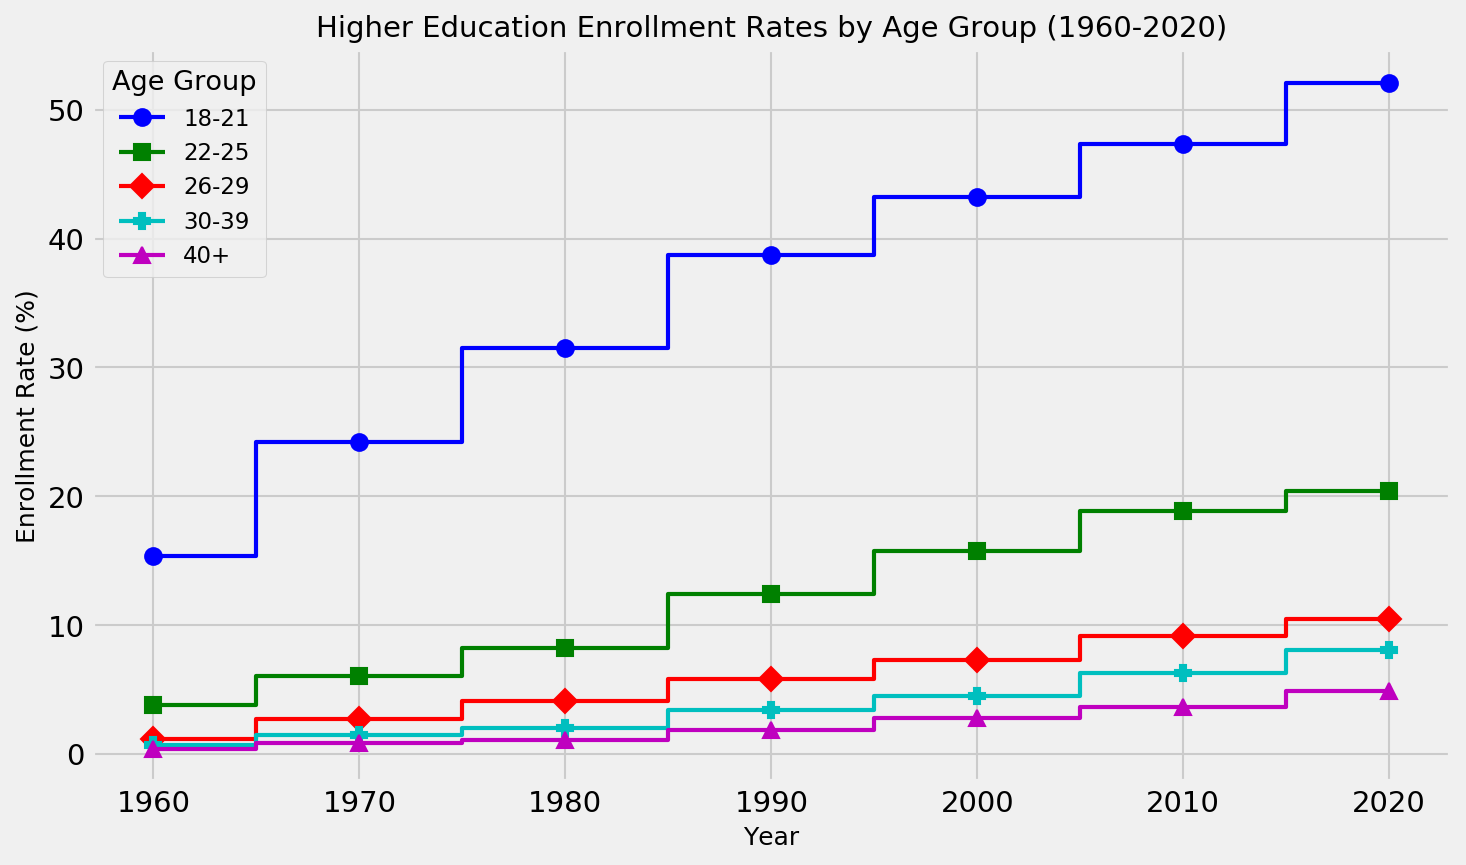What's the enrollment rate trend for the 18-21 age group from 1960 to 2020? From 1960 to 2020, you observe a consistent increase in enrollment rates for the 18-21 age group. Specifically, the rates progress from 15.4% in 1960, to 24.2% in 1970, 31.5% in 1980, 38.7% in 1990, 43.2% in 2000, 47.3% in 2010, and reach 52.1% in 2020.
Answer: Increasing trend Which age group showed the highest enrollment rate increase between 1960 and 2020? To determine this, calculate the differences in enrollment rates for each age group between 1960 and 2020. For the 18-21 age group: 52.1 - 15.4 = 36.7. For the 22-25 age group: 20.4 - 3.8 = 16.6. For the 26-29 age group: 10.5 - 1.2 = 9.3. For the 30-39 age group: 8.1 - 0.7 = 7.4. For the 40+ age group: 4.9 - 0.4 = 4.5. The 18-21 age group shows the highest increase of 36.7 percentage points.
Answer: 18-21 age group Which age group had the lowest enrollment rate in 1980? By referring to the figure, we look at the enrollment rates for each age group in 1980: 18-21 (31.5%), 22-25 (8.2%), 26-29 (4.1%), 30-39 (2.0%), and 40+ (1.1%). The 40+ age group had the lowest enrollment rate in 1980.
Answer: 40+ age group Compare the enrollment rate of the 22-25 age group in 2010 to the 26-29 age group in 2000. Which was higher? The enrollment rate for the 22-25 age group in 2010 is 18.9%, and for the 26-29 age group in 2000, it is 7.3%. Therefore, the enrollment rate for the 22-25 age group in 2010 is higher.
Answer: 22-25 age group in 2010 What's the difference in enrollment rates between the 18-21 and 40+ age groups in 2020? In 2020, the enrollment rate for the 18-21 age group is 52.1%, while for the 40+ age group, it is 4.9%. The difference is 52.1% - 4.9% = 47.2%.
Answer: 47.2% Which age group had a steady increase in enrollment rates without any dips from 1960 to 2020? Examining each age group’s trend: the 18-21, 22-25, 26-29, 30-39, and 40+ groups all show consistent increases without any noticeable dips in the enrollment rates from 1960 to 2020.
Answer: All age groups What is the average enrollment rate of the 30-39 age group across all years presented? To find the average, add the enrollment rates of the 30-39 age group from all years and divide by the number of years: (0.7 + 1.5 + 2.0 + 3.4 + 4.5 + 6.3 + 8.1) / 7 = 26.5 / 7 ≈ 3.79%.
Answer: 3.79% How does the enrollment rate in 1990 for the 18-21 age group compare to the 22-25 age group in the same year? In 1990, the 18-21 age group's enrollment rate is 38.7%, and the 22-25 age group is 12.4%. The 18-21 age group's rate is much higher.
Answer: 18-21 age group Which decade had the highest increase in the enrollment rate for the 18-21 age group? To identify the highest increase, calculate the differences between each decade: (2020-2010: 52.1 - 47.3 = 4.8), (2010-2000: 47.3 - 43.2 = 4.1), (2000-1990: 43.2 - 38.7 = 4.5), (1990-1980: 38.7 - 31.5 = 7.2), (1980-1970: 31.5 - 24.2 = 7.3), (1970-1960: 24.2 - 15.4 = 8.8). The decade with the highest increase is 1960 to 1970 with an increase of 8.8 percentage points.
Answer: 1960 to 1970 